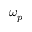Convert formula to latex. <formula><loc_0><loc_0><loc_500><loc_500>\omega _ { p }</formula> 